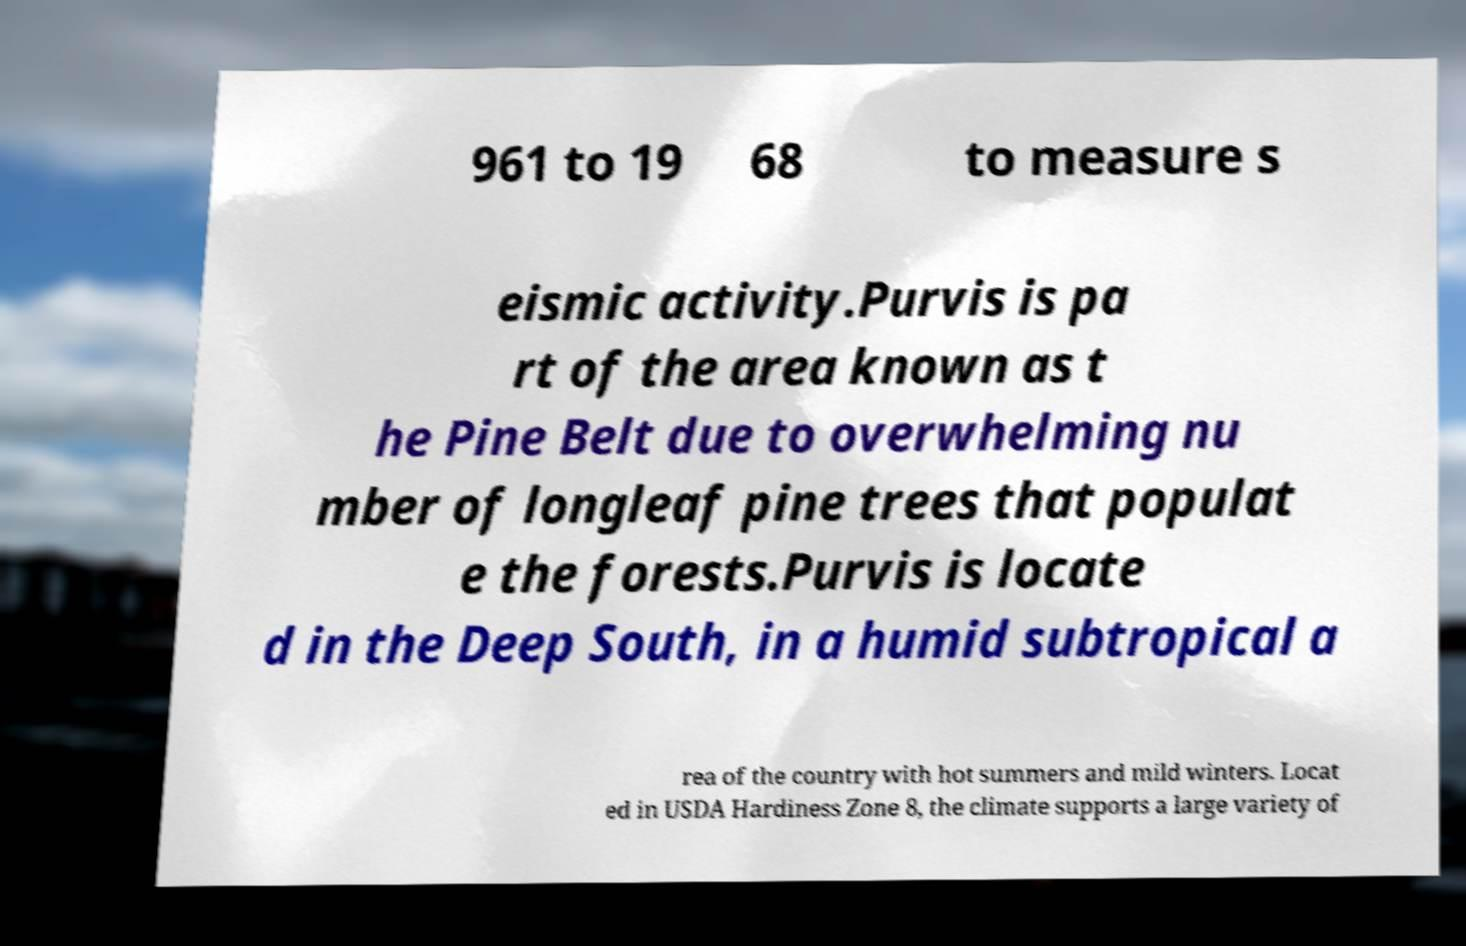For documentation purposes, I need the text within this image transcribed. Could you provide that? 961 to 19 68 to measure s eismic activity.Purvis is pa rt of the area known as t he Pine Belt due to overwhelming nu mber of longleaf pine trees that populat e the forests.Purvis is locate d in the Deep South, in a humid subtropical a rea of the country with hot summers and mild winters. Locat ed in USDA Hardiness Zone 8, the climate supports a large variety of 